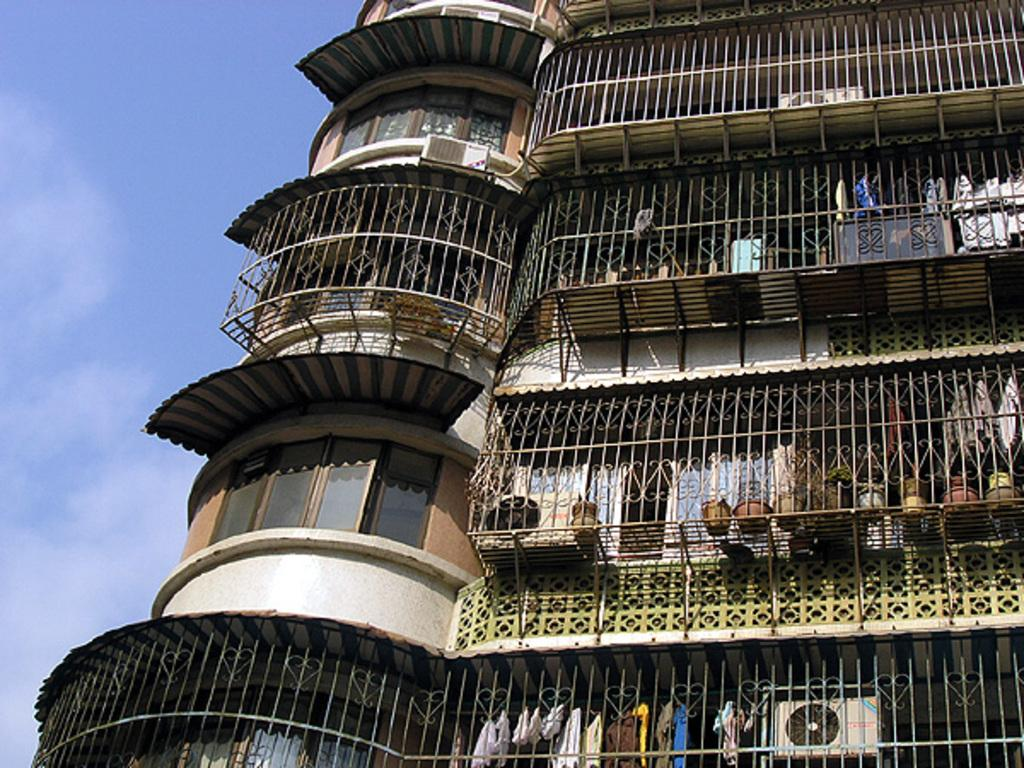What type of structure is present in the image? There is a building in the image. What can be seen on the building in the image? There is a window with glass in the image. What objects are related to plants in the image? There are flower pots in the image. What items are related to clothing in the image? There are clothes visible in the image. What is used for cooking in the image? There is a grill in the image. What part of the natural environment is visible in the image? The sky is visible in the image. What type of paper can be seen being used for a chess game in the image? There is no paper or chess game present in the image. Can you tell me where the mom is sitting in the image? There is no mom or any indication of a person sitting in the image. 